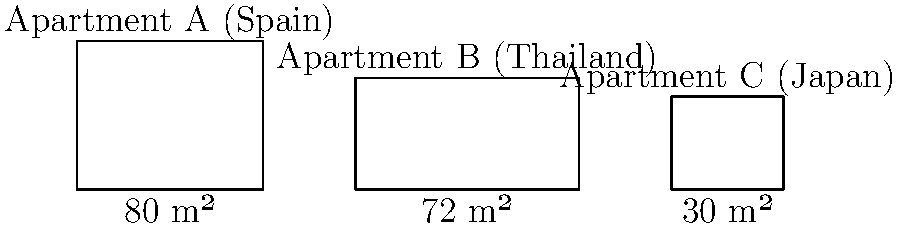As an expat investor, you're comparing floor plans of apartments in different countries. The image shows three apartments: A in Spain (80 m²), B in Thailand (72 m²), and C in Japan (30 m²). If you want to maximize living space while keeping costs reasonable, which apartment offers the best balance of size and potential affordability, assuming that property prices generally correlate with apartment size and location popularity? To determine the best balance of size and potential affordability, we need to consider several factors:

1. Size comparison:
   Apartment A (Spain): 80 m²
   Apartment B (Thailand): 72 m²
   Apartment C (Japan): 30 m²

2. Location considerations:
   - Spain is generally more expensive than Thailand but less expensive than Japan.
   - Japan, especially in urban areas, is known for high property prices.
   - Thailand often offers more affordable real estate options.

3. Size-to-affordability ratio:
   - Apartment A is the largest but may be more expensive due to its size and location in Spain.
   - Apartment C is the smallest and, despite being in Japan, may not offer enough space for comfortable living.
   - Apartment B offers a good compromise between size and potential affordability.

4. Investment potential:
   - Thailand's real estate market often attracts foreign investors due to relatively lower prices and good rental yields.
   - Apartment B's size (72 m²) is suitable for both living and potential rental income.

Considering these factors, Apartment B in Thailand offers the best balance of size and potential affordability. It provides ample living space (72 m²) while likely being more affordable than the Spanish option and offering better value for money than the small Japanese apartment.
Answer: Apartment B (Thailand) 